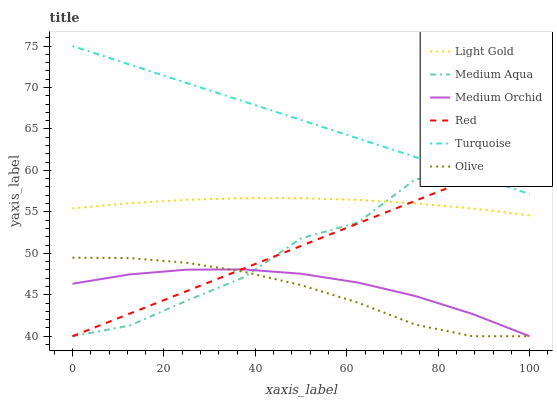Does Olive have the minimum area under the curve?
Answer yes or no. Yes. Does Turquoise have the maximum area under the curve?
Answer yes or no. Yes. Does Medium Orchid have the minimum area under the curve?
Answer yes or no. No. Does Medium Orchid have the maximum area under the curve?
Answer yes or no. No. Is Red the smoothest?
Answer yes or no. Yes. Is Medium Aqua the roughest?
Answer yes or no. Yes. Is Medium Orchid the smoothest?
Answer yes or no. No. Is Medium Orchid the roughest?
Answer yes or no. No. Does Medium Orchid have the lowest value?
Answer yes or no. Yes. Does Light Gold have the lowest value?
Answer yes or no. No. Does Turquoise have the highest value?
Answer yes or no. Yes. Does Medium Aqua have the highest value?
Answer yes or no. No. Is Medium Orchid less than Light Gold?
Answer yes or no. Yes. Is Light Gold greater than Olive?
Answer yes or no. Yes. Does Turquoise intersect Red?
Answer yes or no. Yes. Is Turquoise less than Red?
Answer yes or no. No. Is Turquoise greater than Red?
Answer yes or no. No. Does Medium Orchid intersect Light Gold?
Answer yes or no. No. 